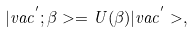Convert formula to latex. <formula><loc_0><loc_0><loc_500><loc_500>| v a c ^ { ^ { \prime } } ; \beta > = U ( \beta ) | v a c ^ { ^ { \prime } } > ,</formula> 